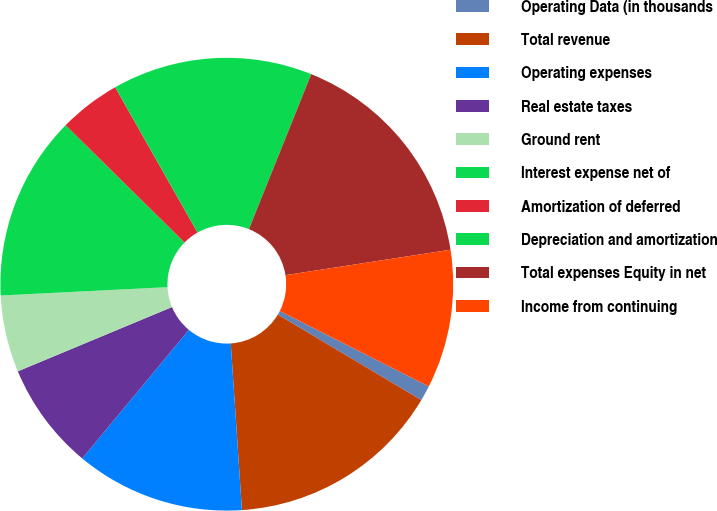<chart> <loc_0><loc_0><loc_500><loc_500><pie_chart><fcel>Operating Data (in thousands<fcel>Total revenue<fcel>Operating expenses<fcel>Real estate taxes<fcel>Ground rent<fcel>Interest expense net of<fcel>Amortization of deferred<fcel>Depreciation and amortization<fcel>Total expenses Equity in net<fcel>Income from continuing<nl><fcel>1.1%<fcel>15.38%<fcel>12.09%<fcel>7.69%<fcel>5.49%<fcel>13.19%<fcel>4.4%<fcel>14.29%<fcel>16.48%<fcel>9.89%<nl></chart> 